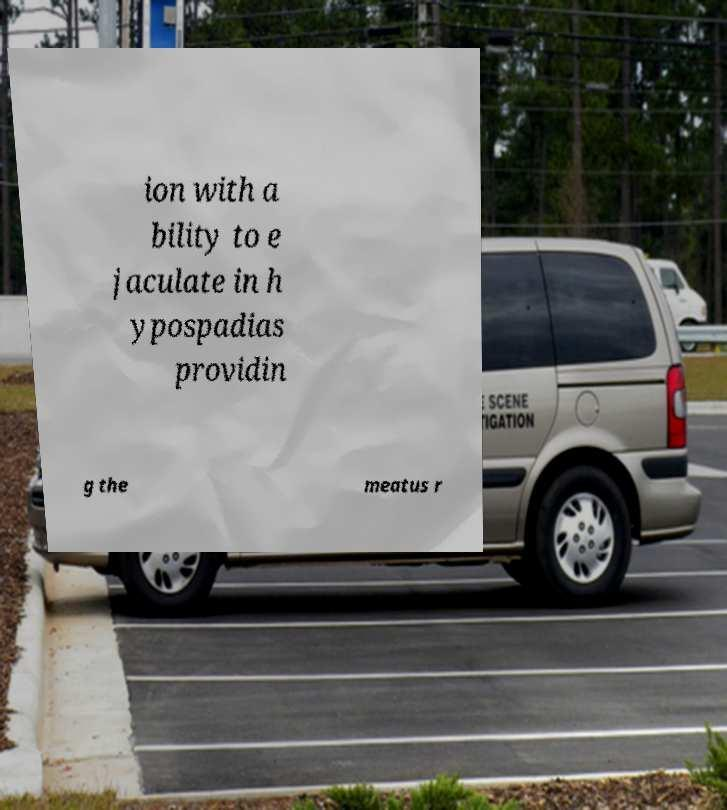I need the written content from this picture converted into text. Can you do that? ion with a bility to e jaculate in h ypospadias providin g the meatus r 